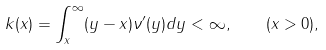<formula> <loc_0><loc_0><loc_500><loc_500>k ( x ) = \int _ { x } ^ { \infty } ( y - x ) { \nu } ^ { \prime } ( y ) d y < \infty , \quad ( x > 0 ) ,</formula> 